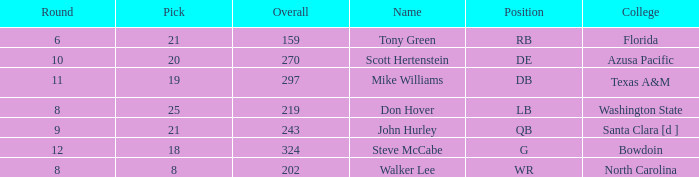Which college has a pick less than 25, an overall greater than 159, a round less than 10, and wr as the position? North Carolina. 